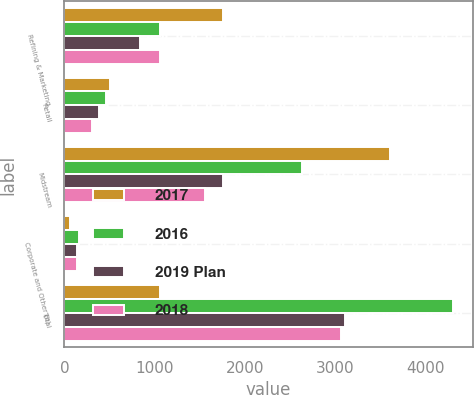<chart> <loc_0><loc_0><loc_500><loc_500><stacked_bar_chart><ecel><fcel>Refining & Marketing<fcel>Retail<fcel>Midstream<fcel>Corporate and Other (b)<fcel>Total<nl><fcel>2017<fcel>1750<fcel>500<fcel>3600<fcel>60<fcel>1054<nl><fcel>2016<fcel>1057<fcel>460<fcel>2630<fcel>157<fcel>4304<nl><fcel>2019 Plan<fcel>832<fcel>381<fcel>1755<fcel>138<fcel>3106<nl><fcel>2018<fcel>1054<fcel>303<fcel>1558<fcel>144<fcel>3059<nl></chart> 